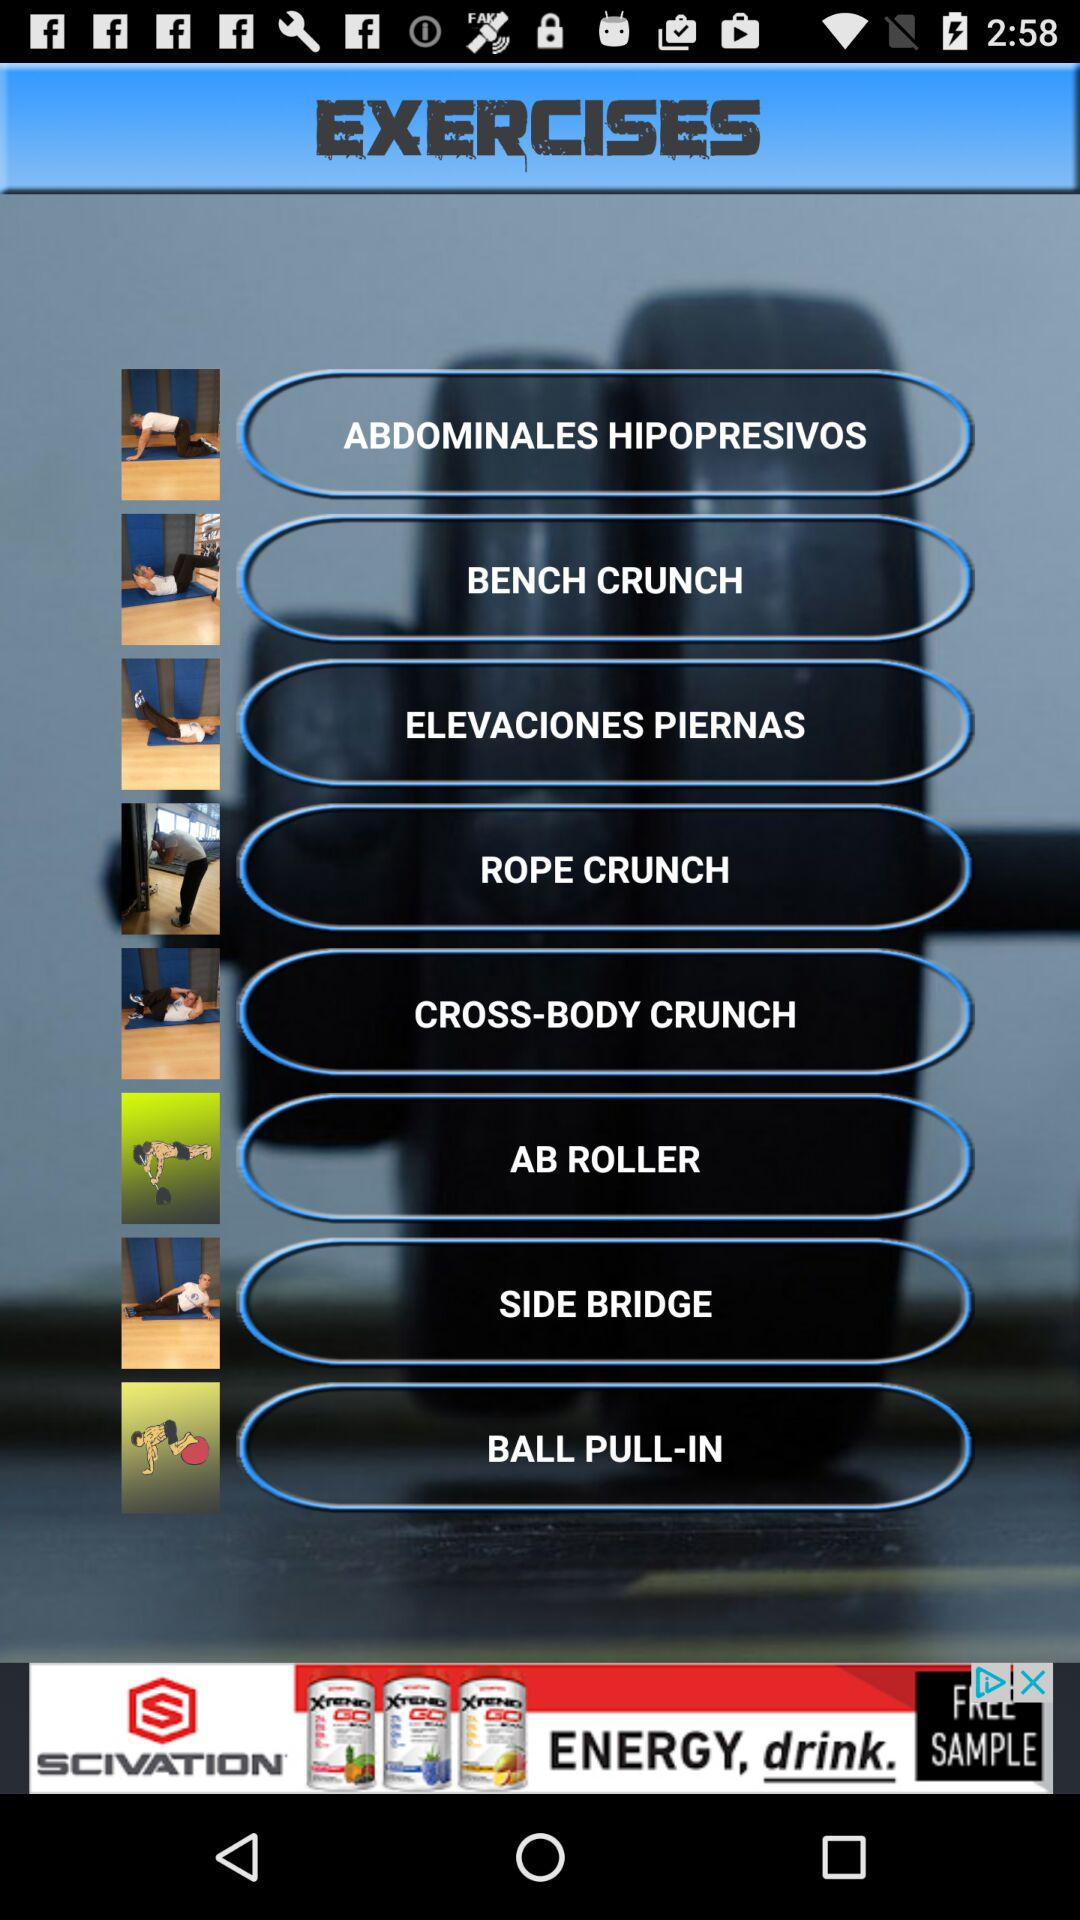What is the application name? The application name is "EXERCISES". 